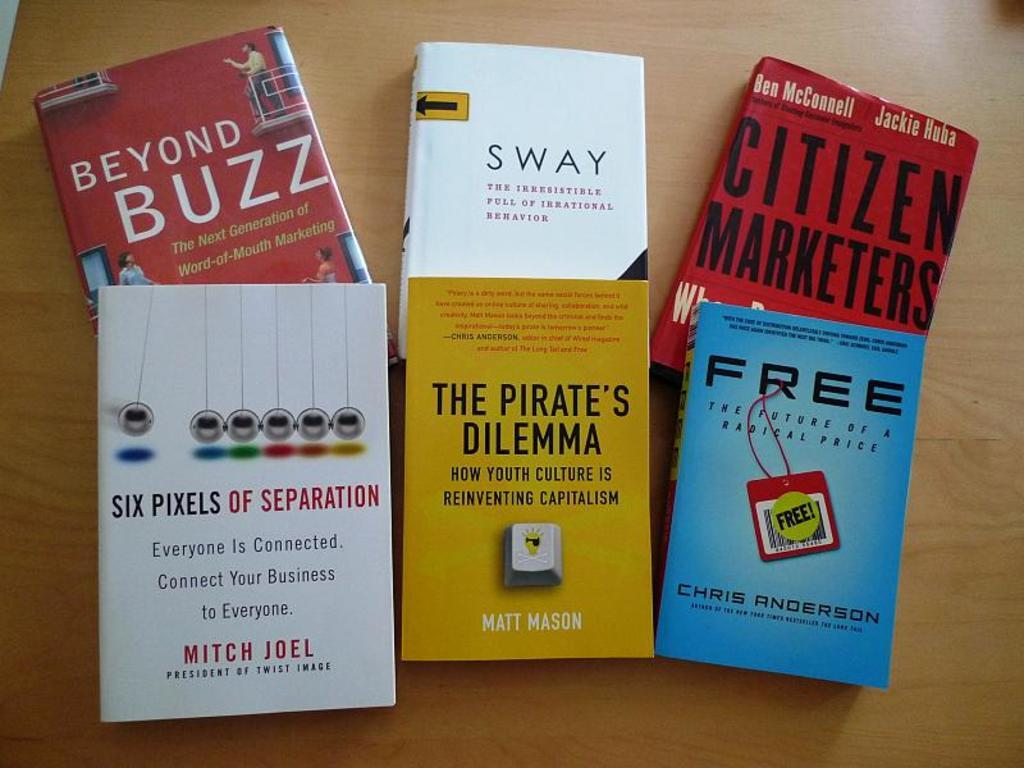<image>
Create a compact narrative representing the image presented. Books on a table that are business related Six Pixels of Separation. 